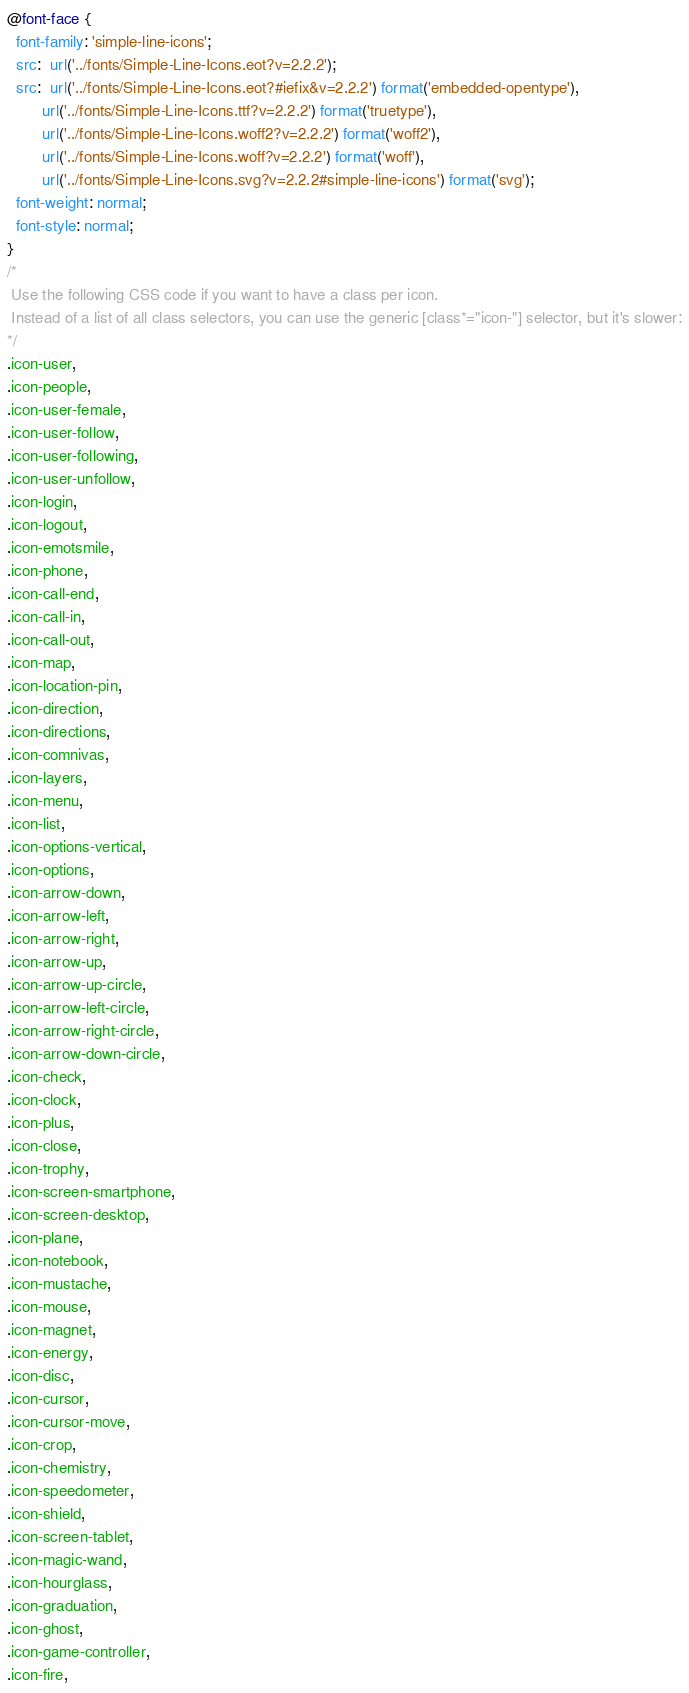Convert code to text. <code><loc_0><loc_0><loc_500><loc_500><_CSS_>@font-face {
  font-family: 'simple-line-icons';
  src:  url('../fonts/Simple-Line-Icons.eot?v=2.2.2');
  src:  url('../fonts/Simple-Line-Icons.eot?#iefix&v=2.2.2') format('embedded-opentype'),
        url('../fonts/Simple-Line-Icons.ttf?v=2.2.2') format('truetype'),
        url('../fonts/Simple-Line-Icons.woff2?v=2.2.2') format('woff2'),
        url('../fonts/Simple-Line-Icons.woff?v=2.2.2') format('woff'),
        url('../fonts/Simple-Line-Icons.svg?v=2.2.2#simple-line-icons') format('svg');
  font-weight: normal;
  font-style: normal;
}
/*
 Use the following CSS code if you want to have a class per icon.
 Instead of a list of all class selectors, you can use the generic [class*="icon-"] selector, but it's slower:
*/
.icon-user,
.icon-people,
.icon-user-female,
.icon-user-follow,
.icon-user-following,
.icon-user-unfollow,
.icon-login,
.icon-logout,
.icon-emotsmile,
.icon-phone,
.icon-call-end,
.icon-call-in,
.icon-call-out,
.icon-map,
.icon-location-pin,
.icon-direction,
.icon-directions,
.icon-comnivas,
.icon-layers,
.icon-menu,
.icon-list,
.icon-options-vertical,
.icon-options,
.icon-arrow-down,
.icon-arrow-left,
.icon-arrow-right,
.icon-arrow-up,
.icon-arrow-up-circle,
.icon-arrow-left-circle,
.icon-arrow-right-circle,
.icon-arrow-down-circle,
.icon-check,
.icon-clock,
.icon-plus,
.icon-close,
.icon-trophy,
.icon-screen-smartphone,
.icon-screen-desktop,
.icon-plane,
.icon-notebook,
.icon-mustache,
.icon-mouse,
.icon-magnet,
.icon-energy,
.icon-disc,
.icon-cursor,
.icon-cursor-move,
.icon-crop,
.icon-chemistry,
.icon-speedometer,
.icon-shield,
.icon-screen-tablet,
.icon-magic-wand,
.icon-hourglass,
.icon-graduation,
.icon-ghost,
.icon-game-controller,
.icon-fire,</code> 